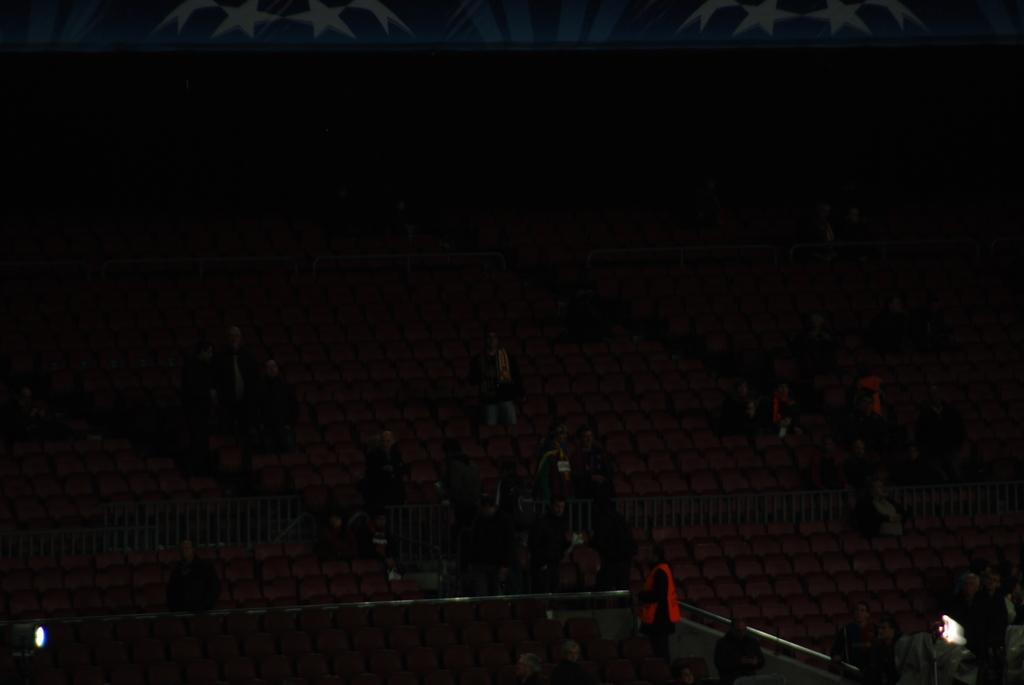What is the main subject in the image? There is a person in the image. What type of furniture is visible in the image? There are chairs in the image. What type of illumination is present in the image? There are lights in the image. What other objects can be seen in the image besides the person and chairs? Other objects are present in the image. How would you describe the overall lighting in the image? The image is dark. What type of sticks are being used by the person in the image? There are no sticks visible in the image. 